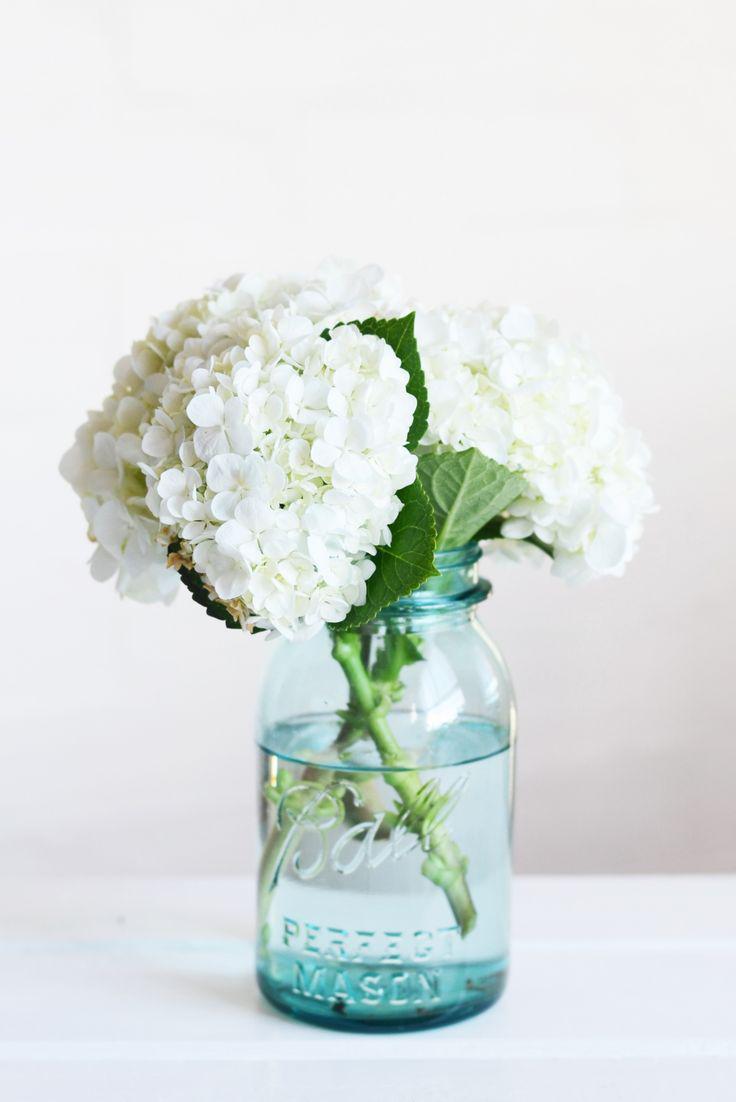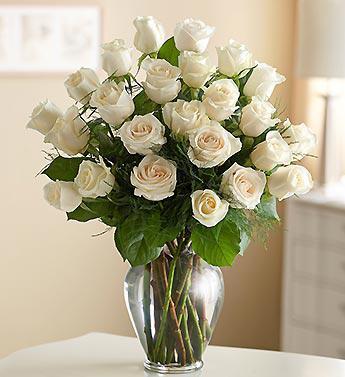The first image is the image on the left, the second image is the image on the right. Examine the images to the left and right. Is the description "There are multiple vases in the right image with the centre one the highest." accurate? Answer yes or no. No. 